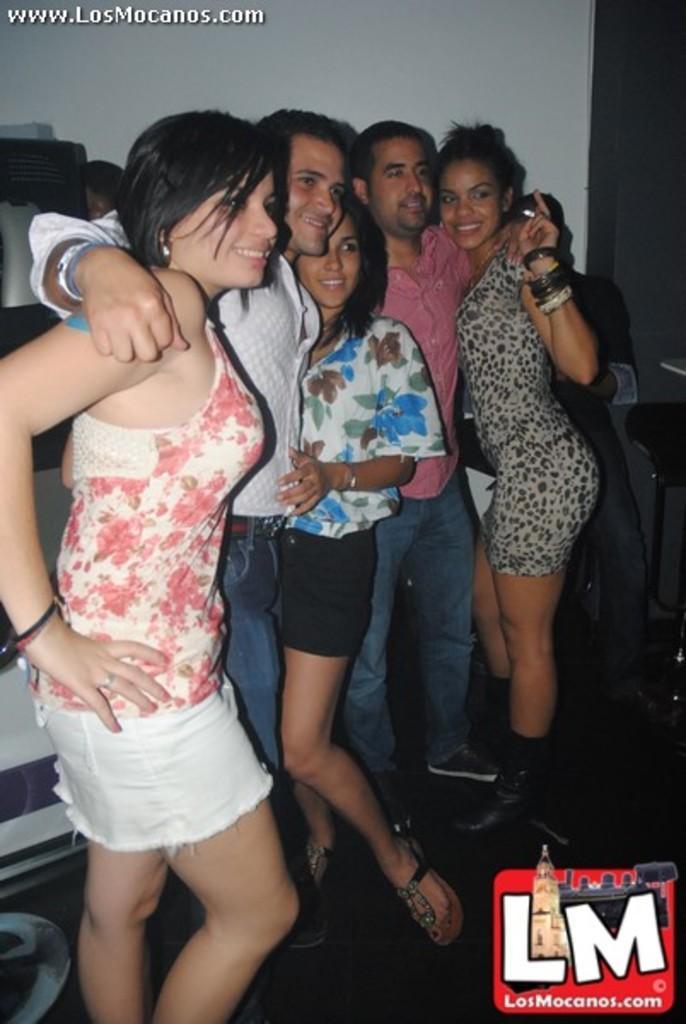Could you give a brief overview of what you see in this image? In this image we can see a few people, beside to them there is a chair, behind them, we can see the wall, also there are text on the image. 